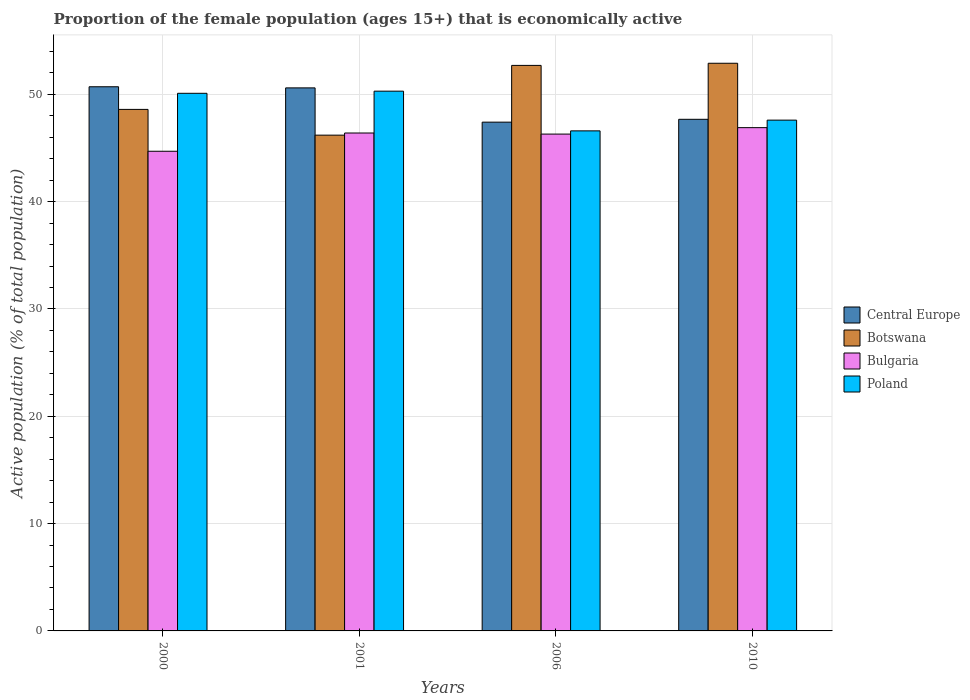Are the number of bars on each tick of the X-axis equal?
Offer a terse response. Yes. How many bars are there on the 4th tick from the left?
Provide a short and direct response. 4. How many bars are there on the 2nd tick from the right?
Give a very brief answer. 4. In how many cases, is the number of bars for a given year not equal to the number of legend labels?
Your response must be concise. 0. What is the proportion of the female population that is economically active in Botswana in 2006?
Your response must be concise. 52.7. Across all years, what is the maximum proportion of the female population that is economically active in Bulgaria?
Make the answer very short. 46.9. Across all years, what is the minimum proportion of the female population that is economically active in Poland?
Your answer should be compact. 46.6. In which year was the proportion of the female population that is economically active in Central Europe maximum?
Offer a terse response. 2000. What is the total proportion of the female population that is economically active in Central Europe in the graph?
Your answer should be compact. 196.41. What is the difference between the proportion of the female population that is economically active in Bulgaria in 2000 and that in 2006?
Your response must be concise. -1.6. What is the difference between the proportion of the female population that is economically active in Botswana in 2001 and the proportion of the female population that is economically active in Bulgaria in 2006?
Make the answer very short. -0.1. What is the average proportion of the female population that is economically active in Poland per year?
Keep it short and to the point. 48.65. In the year 2006, what is the difference between the proportion of the female population that is economically active in Botswana and proportion of the female population that is economically active in Bulgaria?
Provide a succinct answer. 6.4. What is the ratio of the proportion of the female population that is economically active in Bulgaria in 2000 to that in 2010?
Make the answer very short. 0.95. Is the proportion of the female population that is economically active in Bulgaria in 2001 less than that in 2010?
Provide a succinct answer. Yes. Is the difference between the proportion of the female population that is economically active in Botswana in 2000 and 2001 greater than the difference between the proportion of the female population that is economically active in Bulgaria in 2000 and 2001?
Provide a short and direct response. Yes. What is the difference between the highest and the second highest proportion of the female population that is economically active in Bulgaria?
Offer a terse response. 0.5. What is the difference between the highest and the lowest proportion of the female population that is economically active in Central Europe?
Your response must be concise. 3.3. In how many years, is the proportion of the female population that is economically active in Botswana greater than the average proportion of the female population that is economically active in Botswana taken over all years?
Make the answer very short. 2. What does the 1st bar from the left in 2000 represents?
Your answer should be compact. Central Europe. What does the 3rd bar from the right in 2000 represents?
Your answer should be compact. Botswana. How many years are there in the graph?
Your response must be concise. 4. Does the graph contain grids?
Offer a terse response. Yes. Where does the legend appear in the graph?
Offer a very short reply. Center right. What is the title of the graph?
Provide a short and direct response. Proportion of the female population (ages 15+) that is economically active. What is the label or title of the X-axis?
Your answer should be compact. Years. What is the label or title of the Y-axis?
Keep it short and to the point. Active population (% of total population). What is the Active population (% of total population) in Central Europe in 2000?
Provide a short and direct response. 50.71. What is the Active population (% of total population) of Botswana in 2000?
Make the answer very short. 48.6. What is the Active population (% of total population) in Bulgaria in 2000?
Your response must be concise. 44.7. What is the Active population (% of total population) of Poland in 2000?
Keep it short and to the point. 50.1. What is the Active population (% of total population) in Central Europe in 2001?
Keep it short and to the point. 50.61. What is the Active population (% of total population) of Botswana in 2001?
Ensure brevity in your answer.  46.2. What is the Active population (% of total population) of Bulgaria in 2001?
Make the answer very short. 46.4. What is the Active population (% of total population) in Poland in 2001?
Keep it short and to the point. 50.3. What is the Active population (% of total population) in Central Europe in 2006?
Keep it short and to the point. 47.41. What is the Active population (% of total population) of Botswana in 2006?
Keep it short and to the point. 52.7. What is the Active population (% of total population) in Bulgaria in 2006?
Keep it short and to the point. 46.3. What is the Active population (% of total population) of Poland in 2006?
Provide a succinct answer. 46.6. What is the Active population (% of total population) of Central Europe in 2010?
Keep it short and to the point. 47.68. What is the Active population (% of total population) of Botswana in 2010?
Offer a very short reply. 52.9. What is the Active population (% of total population) in Bulgaria in 2010?
Offer a very short reply. 46.9. What is the Active population (% of total population) in Poland in 2010?
Keep it short and to the point. 47.6. Across all years, what is the maximum Active population (% of total population) in Central Europe?
Make the answer very short. 50.71. Across all years, what is the maximum Active population (% of total population) of Botswana?
Provide a short and direct response. 52.9. Across all years, what is the maximum Active population (% of total population) in Bulgaria?
Your answer should be very brief. 46.9. Across all years, what is the maximum Active population (% of total population) in Poland?
Ensure brevity in your answer.  50.3. Across all years, what is the minimum Active population (% of total population) in Central Europe?
Provide a succinct answer. 47.41. Across all years, what is the minimum Active population (% of total population) of Botswana?
Make the answer very short. 46.2. Across all years, what is the minimum Active population (% of total population) in Bulgaria?
Ensure brevity in your answer.  44.7. Across all years, what is the minimum Active population (% of total population) in Poland?
Your response must be concise. 46.6. What is the total Active population (% of total population) of Central Europe in the graph?
Your answer should be very brief. 196.41. What is the total Active population (% of total population) in Botswana in the graph?
Your response must be concise. 200.4. What is the total Active population (% of total population) of Bulgaria in the graph?
Offer a terse response. 184.3. What is the total Active population (% of total population) of Poland in the graph?
Give a very brief answer. 194.6. What is the difference between the Active population (% of total population) in Central Europe in 2000 and that in 2001?
Your answer should be very brief. 0.1. What is the difference between the Active population (% of total population) in Central Europe in 2000 and that in 2006?
Your answer should be compact. 3.3. What is the difference between the Active population (% of total population) of Central Europe in 2000 and that in 2010?
Your answer should be compact. 3.03. What is the difference between the Active population (% of total population) of Botswana in 2000 and that in 2010?
Offer a terse response. -4.3. What is the difference between the Active population (% of total population) of Central Europe in 2001 and that in 2006?
Your answer should be very brief. 3.19. What is the difference between the Active population (% of total population) of Botswana in 2001 and that in 2006?
Provide a succinct answer. -6.5. What is the difference between the Active population (% of total population) of Poland in 2001 and that in 2006?
Provide a short and direct response. 3.7. What is the difference between the Active population (% of total population) of Central Europe in 2001 and that in 2010?
Offer a terse response. 2.93. What is the difference between the Active population (% of total population) in Botswana in 2001 and that in 2010?
Make the answer very short. -6.7. What is the difference between the Active population (% of total population) in Poland in 2001 and that in 2010?
Offer a very short reply. 2.7. What is the difference between the Active population (% of total population) of Central Europe in 2006 and that in 2010?
Keep it short and to the point. -0.27. What is the difference between the Active population (% of total population) in Botswana in 2006 and that in 2010?
Give a very brief answer. -0.2. What is the difference between the Active population (% of total population) of Poland in 2006 and that in 2010?
Provide a short and direct response. -1. What is the difference between the Active population (% of total population) in Central Europe in 2000 and the Active population (% of total population) in Botswana in 2001?
Offer a terse response. 4.51. What is the difference between the Active population (% of total population) in Central Europe in 2000 and the Active population (% of total population) in Bulgaria in 2001?
Make the answer very short. 4.31. What is the difference between the Active population (% of total population) of Central Europe in 2000 and the Active population (% of total population) of Poland in 2001?
Keep it short and to the point. 0.41. What is the difference between the Active population (% of total population) in Botswana in 2000 and the Active population (% of total population) in Poland in 2001?
Ensure brevity in your answer.  -1.7. What is the difference between the Active population (% of total population) of Bulgaria in 2000 and the Active population (% of total population) of Poland in 2001?
Offer a terse response. -5.6. What is the difference between the Active population (% of total population) of Central Europe in 2000 and the Active population (% of total population) of Botswana in 2006?
Ensure brevity in your answer.  -1.99. What is the difference between the Active population (% of total population) in Central Europe in 2000 and the Active population (% of total population) in Bulgaria in 2006?
Offer a very short reply. 4.41. What is the difference between the Active population (% of total population) of Central Europe in 2000 and the Active population (% of total population) of Poland in 2006?
Ensure brevity in your answer.  4.11. What is the difference between the Active population (% of total population) in Central Europe in 2000 and the Active population (% of total population) in Botswana in 2010?
Give a very brief answer. -2.19. What is the difference between the Active population (% of total population) in Central Europe in 2000 and the Active population (% of total population) in Bulgaria in 2010?
Give a very brief answer. 3.81. What is the difference between the Active population (% of total population) in Central Europe in 2000 and the Active population (% of total population) in Poland in 2010?
Provide a short and direct response. 3.11. What is the difference between the Active population (% of total population) in Botswana in 2000 and the Active population (% of total population) in Poland in 2010?
Provide a succinct answer. 1. What is the difference between the Active population (% of total population) in Bulgaria in 2000 and the Active population (% of total population) in Poland in 2010?
Your answer should be compact. -2.9. What is the difference between the Active population (% of total population) of Central Europe in 2001 and the Active population (% of total population) of Botswana in 2006?
Provide a short and direct response. -2.09. What is the difference between the Active population (% of total population) in Central Europe in 2001 and the Active population (% of total population) in Bulgaria in 2006?
Provide a short and direct response. 4.31. What is the difference between the Active population (% of total population) in Central Europe in 2001 and the Active population (% of total population) in Poland in 2006?
Offer a terse response. 4.01. What is the difference between the Active population (% of total population) in Bulgaria in 2001 and the Active population (% of total population) in Poland in 2006?
Keep it short and to the point. -0.2. What is the difference between the Active population (% of total population) in Central Europe in 2001 and the Active population (% of total population) in Botswana in 2010?
Offer a terse response. -2.29. What is the difference between the Active population (% of total population) in Central Europe in 2001 and the Active population (% of total population) in Bulgaria in 2010?
Make the answer very short. 3.71. What is the difference between the Active population (% of total population) in Central Europe in 2001 and the Active population (% of total population) in Poland in 2010?
Provide a succinct answer. 3.01. What is the difference between the Active population (% of total population) in Botswana in 2001 and the Active population (% of total population) in Bulgaria in 2010?
Make the answer very short. -0.7. What is the difference between the Active population (% of total population) in Bulgaria in 2001 and the Active population (% of total population) in Poland in 2010?
Your answer should be very brief. -1.2. What is the difference between the Active population (% of total population) of Central Europe in 2006 and the Active population (% of total population) of Botswana in 2010?
Offer a terse response. -5.49. What is the difference between the Active population (% of total population) of Central Europe in 2006 and the Active population (% of total population) of Bulgaria in 2010?
Give a very brief answer. 0.51. What is the difference between the Active population (% of total population) of Central Europe in 2006 and the Active population (% of total population) of Poland in 2010?
Keep it short and to the point. -0.19. What is the average Active population (% of total population) in Central Europe per year?
Give a very brief answer. 49.1. What is the average Active population (% of total population) in Botswana per year?
Offer a terse response. 50.1. What is the average Active population (% of total population) in Bulgaria per year?
Ensure brevity in your answer.  46.08. What is the average Active population (% of total population) in Poland per year?
Your answer should be compact. 48.65. In the year 2000, what is the difference between the Active population (% of total population) in Central Europe and Active population (% of total population) in Botswana?
Your response must be concise. 2.11. In the year 2000, what is the difference between the Active population (% of total population) of Central Europe and Active population (% of total population) of Bulgaria?
Provide a short and direct response. 6.01. In the year 2000, what is the difference between the Active population (% of total population) of Central Europe and Active population (% of total population) of Poland?
Your answer should be compact. 0.61. In the year 2000, what is the difference between the Active population (% of total population) in Bulgaria and Active population (% of total population) in Poland?
Your answer should be very brief. -5.4. In the year 2001, what is the difference between the Active population (% of total population) of Central Europe and Active population (% of total population) of Botswana?
Give a very brief answer. 4.41. In the year 2001, what is the difference between the Active population (% of total population) in Central Europe and Active population (% of total population) in Bulgaria?
Your answer should be very brief. 4.21. In the year 2001, what is the difference between the Active population (% of total population) of Central Europe and Active population (% of total population) of Poland?
Your response must be concise. 0.31. In the year 2001, what is the difference between the Active population (% of total population) in Botswana and Active population (% of total population) in Poland?
Your answer should be very brief. -4.1. In the year 2001, what is the difference between the Active population (% of total population) of Bulgaria and Active population (% of total population) of Poland?
Give a very brief answer. -3.9. In the year 2006, what is the difference between the Active population (% of total population) of Central Europe and Active population (% of total population) of Botswana?
Your answer should be compact. -5.29. In the year 2006, what is the difference between the Active population (% of total population) of Central Europe and Active population (% of total population) of Bulgaria?
Your answer should be compact. 1.11. In the year 2006, what is the difference between the Active population (% of total population) of Central Europe and Active population (% of total population) of Poland?
Your answer should be very brief. 0.81. In the year 2006, what is the difference between the Active population (% of total population) in Botswana and Active population (% of total population) in Bulgaria?
Provide a short and direct response. 6.4. In the year 2006, what is the difference between the Active population (% of total population) in Bulgaria and Active population (% of total population) in Poland?
Offer a terse response. -0.3. In the year 2010, what is the difference between the Active population (% of total population) of Central Europe and Active population (% of total population) of Botswana?
Your answer should be compact. -5.22. In the year 2010, what is the difference between the Active population (% of total population) in Central Europe and Active population (% of total population) in Bulgaria?
Provide a succinct answer. 0.78. In the year 2010, what is the difference between the Active population (% of total population) in Central Europe and Active population (% of total population) in Poland?
Your answer should be compact. 0.08. In the year 2010, what is the difference between the Active population (% of total population) of Botswana and Active population (% of total population) of Bulgaria?
Give a very brief answer. 6. In the year 2010, what is the difference between the Active population (% of total population) of Botswana and Active population (% of total population) of Poland?
Your response must be concise. 5.3. In the year 2010, what is the difference between the Active population (% of total population) in Bulgaria and Active population (% of total population) in Poland?
Your answer should be very brief. -0.7. What is the ratio of the Active population (% of total population) in Central Europe in 2000 to that in 2001?
Make the answer very short. 1. What is the ratio of the Active population (% of total population) in Botswana in 2000 to that in 2001?
Your response must be concise. 1.05. What is the ratio of the Active population (% of total population) of Bulgaria in 2000 to that in 2001?
Your answer should be compact. 0.96. What is the ratio of the Active population (% of total population) of Poland in 2000 to that in 2001?
Offer a very short reply. 1. What is the ratio of the Active population (% of total population) of Central Europe in 2000 to that in 2006?
Ensure brevity in your answer.  1.07. What is the ratio of the Active population (% of total population) of Botswana in 2000 to that in 2006?
Your answer should be compact. 0.92. What is the ratio of the Active population (% of total population) of Bulgaria in 2000 to that in 2006?
Your response must be concise. 0.97. What is the ratio of the Active population (% of total population) of Poland in 2000 to that in 2006?
Provide a short and direct response. 1.08. What is the ratio of the Active population (% of total population) in Central Europe in 2000 to that in 2010?
Your response must be concise. 1.06. What is the ratio of the Active population (% of total population) of Botswana in 2000 to that in 2010?
Keep it short and to the point. 0.92. What is the ratio of the Active population (% of total population) in Bulgaria in 2000 to that in 2010?
Keep it short and to the point. 0.95. What is the ratio of the Active population (% of total population) in Poland in 2000 to that in 2010?
Offer a terse response. 1.05. What is the ratio of the Active population (% of total population) of Central Europe in 2001 to that in 2006?
Provide a succinct answer. 1.07. What is the ratio of the Active population (% of total population) of Botswana in 2001 to that in 2006?
Your response must be concise. 0.88. What is the ratio of the Active population (% of total population) in Bulgaria in 2001 to that in 2006?
Offer a very short reply. 1. What is the ratio of the Active population (% of total population) of Poland in 2001 to that in 2006?
Your response must be concise. 1.08. What is the ratio of the Active population (% of total population) in Central Europe in 2001 to that in 2010?
Ensure brevity in your answer.  1.06. What is the ratio of the Active population (% of total population) of Botswana in 2001 to that in 2010?
Offer a very short reply. 0.87. What is the ratio of the Active population (% of total population) in Bulgaria in 2001 to that in 2010?
Provide a short and direct response. 0.99. What is the ratio of the Active population (% of total population) of Poland in 2001 to that in 2010?
Make the answer very short. 1.06. What is the ratio of the Active population (% of total population) in Botswana in 2006 to that in 2010?
Your answer should be very brief. 1. What is the ratio of the Active population (% of total population) in Bulgaria in 2006 to that in 2010?
Ensure brevity in your answer.  0.99. What is the ratio of the Active population (% of total population) in Poland in 2006 to that in 2010?
Offer a terse response. 0.98. What is the difference between the highest and the second highest Active population (% of total population) in Central Europe?
Your answer should be compact. 0.1. What is the difference between the highest and the second highest Active population (% of total population) of Bulgaria?
Your answer should be very brief. 0.5. What is the difference between the highest and the lowest Active population (% of total population) in Central Europe?
Your response must be concise. 3.3. What is the difference between the highest and the lowest Active population (% of total population) in Botswana?
Keep it short and to the point. 6.7. 